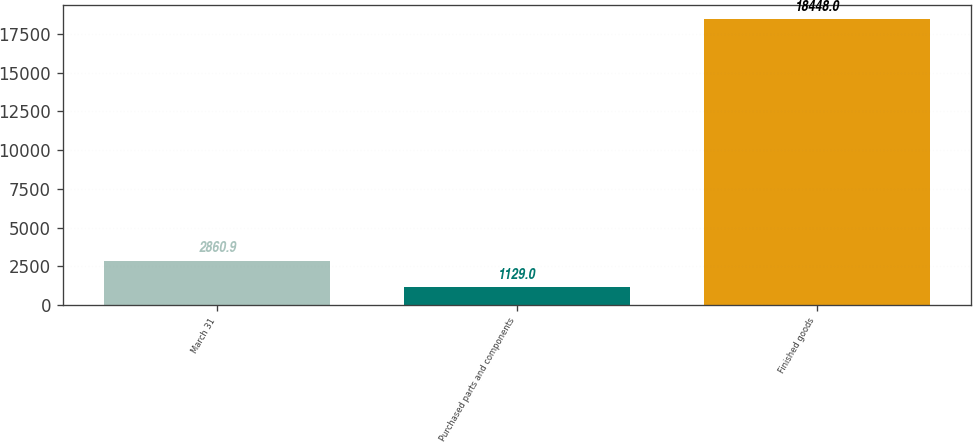Convert chart. <chart><loc_0><loc_0><loc_500><loc_500><bar_chart><fcel>March 31<fcel>Purchased parts and components<fcel>Finished goods<nl><fcel>2860.9<fcel>1129<fcel>18448<nl></chart> 